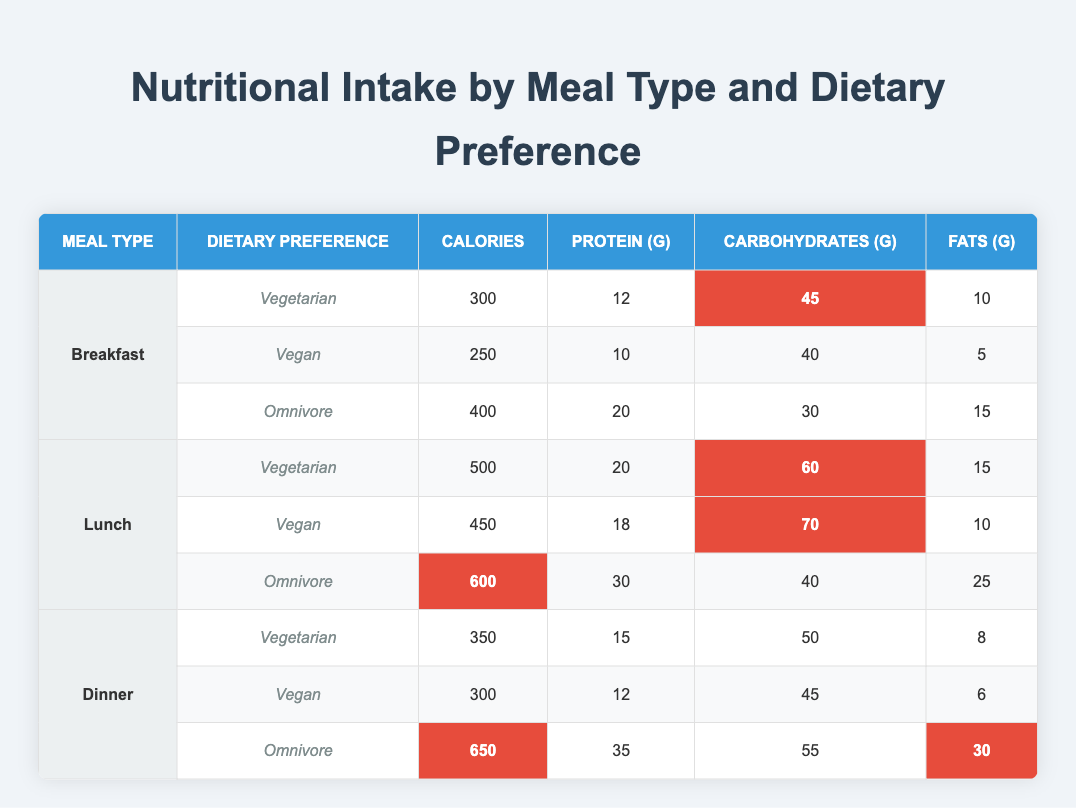What is the highest calorie meal type among the three dietary preferences? To find the highest calorie meal type, we need to look at the calorie counts for each meal type and dietary preference combination. The highest value is 650 calories for Dinner with an Omnivore preference.
Answer: 650 calories What is the total protein content for Vegan meals across all meal types? We need to add the protein values for Vegan meals from each meal type. Breakfast has 10g, Lunch has 18g, and Dinner has 12g. Summing these values: 10 + 18 + 12 = 40g.
Answer: 40g Do Vegetarian meals generally contain more carbohydrates than Vegan meals? We can compare the carbohydrate contents for Vegetarian and Vegan meals across the three meal types. Vegetarian meals have 45g, 60g, and 50g which totals 155g. Vegan meals have 40g, 70g, and 45g which totals 155g. Since both sums are equal, the statement is false.
Answer: No What is the average fat content in Omnivore meals? We need to calculate the average of the fat content for Omnivore meals: 15g for Breakfast, 25g for Lunch, and 30g for Dinner. The total fat is 15 + 25 + 30 = 70g, and there are 3 meals: 70g / 3 = 23.33g.
Answer: 23.33g Is the calorie content for a Vegan lunch higher than that for a Vegetarian breakfast? The Vegan lunch has 450 calories, while the Vegetarian breakfast has 300 calories. Since 450 is greater than 300, the statement is true.
Answer: Yes What is the difference in calories between the highest and lowest calorie meals? The highest calorie meal is 650 calories (Omnivore Dinner), and the lowest is 250 calories (Vegan Breakfast). The difference is 650 - 250 = 400 calories.
Answer: 400 calories How many grams of protein are there in Vegetarian lunch compared to Dinner? The Vegetarian lunch has 20g of protein, while the Vegetarian dinner has 15g. The difference is 20g - 15g = 5g more protein in lunch compared to dinner.
Answer: 5g What meal type has the highest average calories across all dietary preferences? To find this, we calculate the average calories for each meal type: Breakfast (300 + 250 + 400)/3 = 316.67, Lunch (500 + 450 + 600)/3 = 550, Dinner (350 + 300 + 650)/3 = 433.33. The highest average is for Lunch at 550 calories.
Answer: Lunch 